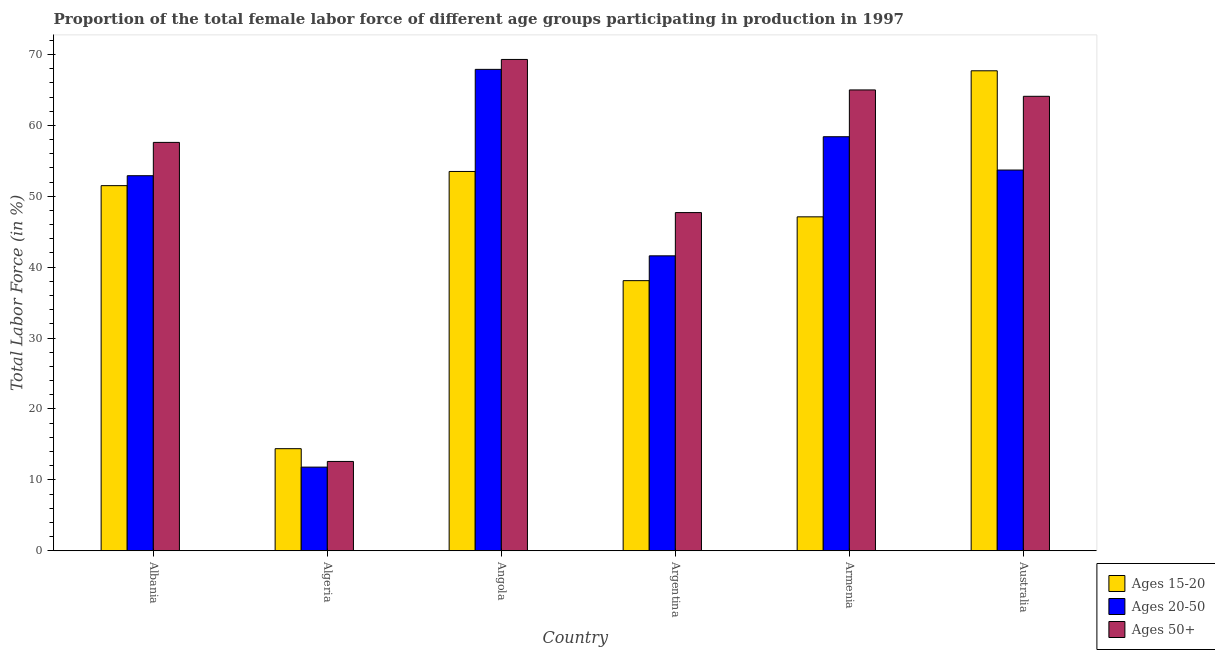How many different coloured bars are there?
Your answer should be compact. 3. Are the number of bars on each tick of the X-axis equal?
Your answer should be compact. Yes. How many bars are there on the 2nd tick from the right?
Your answer should be compact. 3. What is the label of the 3rd group of bars from the left?
Make the answer very short. Angola. In how many cases, is the number of bars for a given country not equal to the number of legend labels?
Give a very brief answer. 0. What is the percentage of female labor force above age 50 in Algeria?
Your response must be concise. 12.6. Across all countries, what is the maximum percentage of female labor force within the age group 15-20?
Provide a short and direct response. 67.7. Across all countries, what is the minimum percentage of female labor force within the age group 15-20?
Your answer should be compact. 14.4. In which country was the percentage of female labor force within the age group 20-50 maximum?
Give a very brief answer. Angola. In which country was the percentage of female labor force within the age group 15-20 minimum?
Ensure brevity in your answer.  Algeria. What is the total percentage of female labor force above age 50 in the graph?
Provide a short and direct response. 316.3. What is the difference between the percentage of female labor force within the age group 20-50 in Albania and that in Angola?
Your response must be concise. -15. What is the difference between the percentage of female labor force within the age group 15-20 in Argentina and the percentage of female labor force above age 50 in Algeria?
Provide a succinct answer. 25.5. What is the average percentage of female labor force within the age group 20-50 per country?
Offer a terse response. 47.72. What is the difference between the percentage of female labor force within the age group 20-50 and percentage of female labor force above age 50 in Armenia?
Your response must be concise. -6.6. What is the ratio of the percentage of female labor force above age 50 in Angola to that in Armenia?
Give a very brief answer. 1.07. What is the difference between the highest and the second highest percentage of female labor force above age 50?
Keep it short and to the point. 4.3. What is the difference between the highest and the lowest percentage of female labor force above age 50?
Offer a terse response. 56.7. Is the sum of the percentage of female labor force above age 50 in Angola and Argentina greater than the maximum percentage of female labor force within the age group 15-20 across all countries?
Provide a short and direct response. Yes. What does the 3rd bar from the left in Algeria represents?
Your answer should be very brief. Ages 50+. What does the 2nd bar from the right in Albania represents?
Ensure brevity in your answer.  Ages 20-50. Is it the case that in every country, the sum of the percentage of female labor force within the age group 15-20 and percentage of female labor force within the age group 20-50 is greater than the percentage of female labor force above age 50?
Your answer should be compact. Yes. Are all the bars in the graph horizontal?
Your answer should be compact. No. How many countries are there in the graph?
Offer a terse response. 6. What is the difference between two consecutive major ticks on the Y-axis?
Offer a terse response. 10. Does the graph contain any zero values?
Offer a very short reply. No. Does the graph contain grids?
Your answer should be compact. No. Where does the legend appear in the graph?
Provide a short and direct response. Bottom right. How many legend labels are there?
Your answer should be very brief. 3. What is the title of the graph?
Make the answer very short. Proportion of the total female labor force of different age groups participating in production in 1997. What is the label or title of the Y-axis?
Give a very brief answer. Total Labor Force (in %). What is the Total Labor Force (in %) of Ages 15-20 in Albania?
Provide a succinct answer. 51.5. What is the Total Labor Force (in %) in Ages 20-50 in Albania?
Your answer should be compact. 52.9. What is the Total Labor Force (in %) of Ages 50+ in Albania?
Your answer should be compact. 57.6. What is the Total Labor Force (in %) in Ages 15-20 in Algeria?
Offer a very short reply. 14.4. What is the Total Labor Force (in %) in Ages 20-50 in Algeria?
Provide a short and direct response. 11.8. What is the Total Labor Force (in %) in Ages 50+ in Algeria?
Offer a terse response. 12.6. What is the Total Labor Force (in %) in Ages 15-20 in Angola?
Offer a very short reply. 53.5. What is the Total Labor Force (in %) in Ages 20-50 in Angola?
Your answer should be very brief. 67.9. What is the Total Labor Force (in %) in Ages 50+ in Angola?
Your response must be concise. 69.3. What is the Total Labor Force (in %) of Ages 15-20 in Argentina?
Offer a terse response. 38.1. What is the Total Labor Force (in %) of Ages 20-50 in Argentina?
Give a very brief answer. 41.6. What is the Total Labor Force (in %) in Ages 50+ in Argentina?
Provide a succinct answer. 47.7. What is the Total Labor Force (in %) in Ages 15-20 in Armenia?
Provide a short and direct response. 47.1. What is the Total Labor Force (in %) in Ages 20-50 in Armenia?
Offer a terse response. 58.4. What is the Total Labor Force (in %) of Ages 15-20 in Australia?
Keep it short and to the point. 67.7. What is the Total Labor Force (in %) in Ages 20-50 in Australia?
Keep it short and to the point. 53.7. What is the Total Labor Force (in %) of Ages 50+ in Australia?
Provide a short and direct response. 64.1. Across all countries, what is the maximum Total Labor Force (in %) of Ages 15-20?
Offer a terse response. 67.7. Across all countries, what is the maximum Total Labor Force (in %) in Ages 20-50?
Your answer should be very brief. 67.9. Across all countries, what is the maximum Total Labor Force (in %) in Ages 50+?
Give a very brief answer. 69.3. Across all countries, what is the minimum Total Labor Force (in %) of Ages 15-20?
Your answer should be compact. 14.4. Across all countries, what is the minimum Total Labor Force (in %) in Ages 20-50?
Your answer should be very brief. 11.8. Across all countries, what is the minimum Total Labor Force (in %) in Ages 50+?
Your response must be concise. 12.6. What is the total Total Labor Force (in %) of Ages 15-20 in the graph?
Keep it short and to the point. 272.3. What is the total Total Labor Force (in %) in Ages 20-50 in the graph?
Offer a terse response. 286.3. What is the total Total Labor Force (in %) in Ages 50+ in the graph?
Offer a terse response. 316.3. What is the difference between the Total Labor Force (in %) of Ages 15-20 in Albania and that in Algeria?
Make the answer very short. 37.1. What is the difference between the Total Labor Force (in %) in Ages 20-50 in Albania and that in Algeria?
Ensure brevity in your answer.  41.1. What is the difference between the Total Labor Force (in %) of Ages 50+ in Albania and that in Algeria?
Provide a short and direct response. 45. What is the difference between the Total Labor Force (in %) of Ages 20-50 in Albania and that in Angola?
Your response must be concise. -15. What is the difference between the Total Labor Force (in %) of Ages 50+ in Albania and that in Argentina?
Ensure brevity in your answer.  9.9. What is the difference between the Total Labor Force (in %) in Ages 15-20 in Albania and that in Armenia?
Your answer should be very brief. 4.4. What is the difference between the Total Labor Force (in %) of Ages 15-20 in Albania and that in Australia?
Your answer should be compact. -16.2. What is the difference between the Total Labor Force (in %) in Ages 15-20 in Algeria and that in Angola?
Your answer should be very brief. -39.1. What is the difference between the Total Labor Force (in %) of Ages 20-50 in Algeria and that in Angola?
Make the answer very short. -56.1. What is the difference between the Total Labor Force (in %) of Ages 50+ in Algeria and that in Angola?
Make the answer very short. -56.7. What is the difference between the Total Labor Force (in %) in Ages 15-20 in Algeria and that in Argentina?
Give a very brief answer. -23.7. What is the difference between the Total Labor Force (in %) in Ages 20-50 in Algeria and that in Argentina?
Your response must be concise. -29.8. What is the difference between the Total Labor Force (in %) of Ages 50+ in Algeria and that in Argentina?
Your answer should be compact. -35.1. What is the difference between the Total Labor Force (in %) of Ages 15-20 in Algeria and that in Armenia?
Provide a succinct answer. -32.7. What is the difference between the Total Labor Force (in %) in Ages 20-50 in Algeria and that in Armenia?
Offer a very short reply. -46.6. What is the difference between the Total Labor Force (in %) in Ages 50+ in Algeria and that in Armenia?
Ensure brevity in your answer.  -52.4. What is the difference between the Total Labor Force (in %) in Ages 15-20 in Algeria and that in Australia?
Give a very brief answer. -53.3. What is the difference between the Total Labor Force (in %) of Ages 20-50 in Algeria and that in Australia?
Your answer should be very brief. -41.9. What is the difference between the Total Labor Force (in %) in Ages 50+ in Algeria and that in Australia?
Ensure brevity in your answer.  -51.5. What is the difference between the Total Labor Force (in %) in Ages 20-50 in Angola and that in Argentina?
Keep it short and to the point. 26.3. What is the difference between the Total Labor Force (in %) of Ages 50+ in Angola and that in Argentina?
Offer a terse response. 21.6. What is the difference between the Total Labor Force (in %) of Ages 15-20 in Angola and that in Australia?
Your response must be concise. -14.2. What is the difference between the Total Labor Force (in %) in Ages 20-50 in Angola and that in Australia?
Your answer should be very brief. 14.2. What is the difference between the Total Labor Force (in %) of Ages 50+ in Angola and that in Australia?
Provide a succinct answer. 5.2. What is the difference between the Total Labor Force (in %) in Ages 15-20 in Argentina and that in Armenia?
Provide a short and direct response. -9. What is the difference between the Total Labor Force (in %) in Ages 20-50 in Argentina and that in Armenia?
Make the answer very short. -16.8. What is the difference between the Total Labor Force (in %) in Ages 50+ in Argentina and that in Armenia?
Ensure brevity in your answer.  -17.3. What is the difference between the Total Labor Force (in %) in Ages 15-20 in Argentina and that in Australia?
Your answer should be very brief. -29.6. What is the difference between the Total Labor Force (in %) in Ages 20-50 in Argentina and that in Australia?
Offer a very short reply. -12.1. What is the difference between the Total Labor Force (in %) of Ages 50+ in Argentina and that in Australia?
Your answer should be compact. -16.4. What is the difference between the Total Labor Force (in %) of Ages 15-20 in Armenia and that in Australia?
Your answer should be compact. -20.6. What is the difference between the Total Labor Force (in %) of Ages 20-50 in Armenia and that in Australia?
Your answer should be compact. 4.7. What is the difference between the Total Labor Force (in %) in Ages 15-20 in Albania and the Total Labor Force (in %) in Ages 20-50 in Algeria?
Give a very brief answer. 39.7. What is the difference between the Total Labor Force (in %) of Ages 15-20 in Albania and the Total Labor Force (in %) of Ages 50+ in Algeria?
Make the answer very short. 38.9. What is the difference between the Total Labor Force (in %) in Ages 20-50 in Albania and the Total Labor Force (in %) in Ages 50+ in Algeria?
Give a very brief answer. 40.3. What is the difference between the Total Labor Force (in %) of Ages 15-20 in Albania and the Total Labor Force (in %) of Ages 20-50 in Angola?
Your answer should be compact. -16.4. What is the difference between the Total Labor Force (in %) in Ages 15-20 in Albania and the Total Labor Force (in %) in Ages 50+ in Angola?
Offer a very short reply. -17.8. What is the difference between the Total Labor Force (in %) in Ages 20-50 in Albania and the Total Labor Force (in %) in Ages 50+ in Angola?
Ensure brevity in your answer.  -16.4. What is the difference between the Total Labor Force (in %) in Ages 15-20 in Albania and the Total Labor Force (in %) in Ages 20-50 in Argentina?
Offer a very short reply. 9.9. What is the difference between the Total Labor Force (in %) in Ages 15-20 in Albania and the Total Labor Force (in %) in Ages 50+ in Argentina?
Offer a very short reply. 3.8. What is the difference between the Total Labor Force (in %) in Ages 20-50 in Albania and the Total Labor Force (in %) in Ages 50+ in Argentina?
Offer a terse response. 5.2. What is the difference between the Total Labor Force (in %) in Ages 15-20 in Albania and the Total Labor Force (in %) in Ages 20-50 in Armenia?
Offer a terse response. -6.9. What is the difference between the Total Labor Force (in %) of Ages 15-20 in Albania and the Total Labor Force (in %) of Ages 50+ in Armenia?
Provide a short and direct response. -13.5. What is the difference between the Total Labor Force (in %) in Ages 20-50 in Albania and the Total Labor Force (in %) in Ages 50+ in Armenia?
Provide a short and direct response. -12.1. What is the difference between the Total Labor Force (in %) in Ages 15-20 in Albania and the Total Labor Force (in %) in Ages 50+ in Australia?
Offer a terse response. -12.6. What is the difference between the Total Labor Force (in %) of Ages 15-20 in Algeria and the Total Labor Force (in %) of Ages 20-50 in Angola?
Your answer should be compact. -53.5. What is the difference between the Total Labor Force (in %) in Ages 15-20 in Algeria and the Total Labor Force (in %) in Ages 50+ in Angola?
Your response must be concise. -54.9. What is the difference between the Total Labor Force (in %) in Ages 20-50 in Algeria and the Total Labor Force (in %) in Ages 50+ in Angola?
Keep it short and to the point. -57.5. What is the difference between the Total Labor Force (in %) of Ages 15-20 in Algeria and the Total Labor Force (in %) of Ages 20-50 in Argentina?
Your answer should be compact. -27.2. What is the difference between the Total Labor Force (in %) in Ages 15-20 in Algeria and the Total Labor Force (in %) in Ages 50+ in Argentina?
Make the answer very short. -33.3. What is the difference between the Total Labor Force (in %) in Ages 20-50 in Algeria and the Total Labor Force (in %) in Ages 50+ in Argentina?
Provide a succinct answer. -35.9. What is the difference between the Total Labor Force (in %) of Ages 15-20 in Algeria and the Total Labor Force (in %) of Ages 20-50 in Armenia?
Provide a succinct answer. -44. What is the difference between the Total Labor Force (in %) in Ages 15-20 in Algeria and the Total Labor Force (in %) in Ages 50+ in Armenia?
Your response must be concise. -50.6. What is the difference between the Total Labor Force (in %) of Ages 20-50 in Algeria and the Total Labor Force (in %) of Ages 50+ in Armenia?
Make the answer very short. -53.2. What is the difference between the Total Labor Force (in %) of Ages 15-20 in Algeria and the Total Labor Force (in %) of Ages 20-50 in Australia?
Your response must be concise. -39.3. What is the difference between the Total Labor Force (in %) in Ages 15-20 in Algeria and the Total Labor Force (in %) in Ages 50+ in Australia?
Your response must be concise. -49.7. What is the difference between the Total Labor Force (in %) in Ages 20-50 in Algeria and the Total Labor Force (in %) in Ages 50+ in Australia?
Your answer should be compact. -52.3. What is the difference between the Total Labor Force (in %) of Ages 15-20 in Angola and the Total Labor Force (in %) of Ages 50+ in Argentina?
Make the answer very short. 5.8. What is the difference between the Total Labor Force (in %) in Ages 20-50 in Angola and the Total Labor Force (in %) in Ages 50+ in Argentina?
Your response must be concise. 20.2. What is the difference between the Total Labor Force (in %) of Ages 15-20 in Angola and the Total Labor Force (in %) of Ages 20-50 in Armenia?
Provide a short and direct response. -4.9. What is the difference between the Total Labor Force (in %) in Ages 15-20 in Angola and the Total Labor Force (in %) in Ages 50+ in Armenia?
Keep it short and to the point. -11.5. What is the difference between the Total Labor Force (in %) of Ages 20-50 in Angola and the Total Labor Force (in %) of Ages 50+ in Armenia?
Offer a terse response. 2.9. What is the difference between the Total Labor Force (in %) of Ages 15-20 in Angola and the Total Labor Force (in %) of Ages 20-50 in Australia?
Your answer should be very brief. -0.2. What is the difference between the Total Labor Force (in %) of Ages 15-20 in Angola and the Total Labor Force (in %) of Ages 50+ in Australia?
Your answer should be compact. -10.6. What is the difference between the Total Labor Force (in %) of Ages 15-20 in Argentina and the Total Labor Force (in %) of Ages 20-50 in Armenia?
Provide a succinct answer. -20.3. What is the difference between the Total Labor Force (in %) of Ages 15-20 in Argentina and the Total Labor Force (in %) of Ages 50+ in Armenia?
Your answer should be compact. -26.9. What is the difference between the Total Labor Force (in %) in Ages 20-50 in Argentina and the Total Labor Force (in %) in Ages 50+ in Armenia?
Keep it short and to the point. -23.4. What is the difference between the Total Labor Force (in %) of Ages 15-20 in Argentina and the Total Labor Force (in %) of Ages 20-50 in Australia?
Provide a succinct answer. -15.6. What is the difference between the Total Labor Force (in %) in Ages 15-20 in Argentina and the Total Labor Force (in %) in Ages 50+ in Australia?
Your answer should be very brief. -26. What is the difference between the Total Labor Force (in %) of Ages 20-50 in Argentina and the Total Labor Force (in %) of Ages 50+ in Australia?
Offer a terse response. -22.5. What is the difference between the Total Labor Force (in %) in Ages 15-20 in Armenia and the Total Labor Force (in %) in Ages 20-50 in Australia?
Provide a succinct answer. -6.6. What is the difference between the Total Labor Force (in %) of Ages 15-20 in Armenia and the Total Labor Force (in %) of Ages 50+ in Australia?
Offer a very short reply. -17. What is the average Total Labor Force (in %) of Ages 15-20 per country?
Your response must be concise. 45.38. What is the average Total Labor Force (in %) in Ages 20-50 per country?
Offer a terse response. 47.72. What is the average Total Labor Force (in %) of Ages 50+ per country?
Your answer should be compact. 52.72. What is the difference between the Total Labor Force (in %) of Ages 15-20 and Total Labor Force (in %) of Ages 20-50 in Albania?
Make the answer very short. -1.4. What is the difference between the Total Labor Force (in %) of Ages 15-20 and Total Labor Force (in %) of Ages 50+ in Albania?
Ensure brevity in your answer.  -6.1. What is the difference between the Total Labor Force (in %) in Ages 15-20 and Total Labor Force (in %) in Ages 20-50 in Algeria?
Give a very brief answer. 2.6. What is the difference between the Total Labor Force (in %) of Ages 15-20 and Total Labor Force (in %) of Ages 20-50 in Angola?
Your response must be concise. -14.4. What is the difference between the Total Labor Force (in %) in Ages 15-20 and Total Labor Force (in %) in Ages 50+ in Angola?
Give a very brief answer. -15.8. What is the difference between the Total Labor Force (in %) of Ages 20-50 and Total Labor Force (in %) of Ages 50+ in Angola?
Keep it short and to the point. -1.4. What is the difference between the Total Labor Force (in %) in Ages 15-20 and Total Labor Force (in %) in Ages 20-50 in Argentina?
Give a very brief answer. -3.5. What is the difference between the Total Labor Force (in %) of Ages 15-20 and Total Labor Force (in %) of Ages 50+ in Armenia?
Provide a short and direct response. -17.9. What is the difference between the Total Labor Force (in %) of Ages 20-50 and Total Labor Force (in %) of Ages 50+ in Armenia?
Make the answer very short. -6.6. What is the difference between the Total Labor Force (in %) of Ages 15-20 and Total Labor Force (in %) of Ages 50+ in Australia?
Offer a very short reply. 3.6. What is the ratio of the Total Labor Force (in %) in Ages 15-20 in Albania to that in Algeria?
Offer a terse response. 3.58. What is the ratio of the Total Labor Force (in %) in Ages 20-50 in Albania to that in Algeria?
Keep it short and to the point. 4.48. What is the ratio of the Total Labor Force (in %) of Ages 50+ in Albania to that in Algeria?
Keep it short and to the point. 4.57. What is the ratio of the Total Labor Force (in %) of Ages 15-20 in Albania to that in Angola?
Make the answer very short. 0.96. What is the ratio of the Total Labor Force (in %) in Ages 20-50 in Albania to that in Angola?
Make the answer very short. 0.78. What is the ratio of the Total Labor Force (in %) in Ages 50+ in Albania to that in Angola?
Keep it short and to the point. 0.83. What is the ratio of the Total Labor Force (in %) of Ages 15-20 in Albania to that in Argentina?
Ensure brevity in your answer.  1.35. What is the ratio of the Total Labor Force (in %) in Ages 20-50 in Albania to that in Argentina?
Your response must be concise. 1.27. What is the ratio of the Total Labor Force (in %) of Ages 50+ in Albania to that in Argentina?
Offer a very short reply. 1.21. What is the ratio of the Total Labor Force (in %) in Ages 15-20 in Albania to that in Armenia?
Your response must be concise. 1.09. What is the ratio of the Total Labor Force (in %) in Ages 20-50 in Albania to that in Armenia?
Keep it short and to the point. 0.91. What is the ratio of the Total Labor Force (in %) in Ages 50+ in Albania to that in Armenia?
Give a very brief answer. 0.89. What is the ratio of the Total Labor Force (in %) in Ages 15-20 in Albania to that in Australia?
Offer a very short reply. 0.76. What is the ratio of the Total Labor Force (in %) of Ages 20-50 in Albania to that in Australia?
Offer a very short reply. 0.99. What is the ratio of the Total Labor Force (in %) of Ages 50+ in Albania to that in Australia?
Ensure brevity in your answer.  0.9. What is the ratio of the Total Labor Force (in %) of Ages 15-20 in Algeria to that in Angola?
Provide a short and direct response. 0.27. What is the ratio of the Total Labor Force (in %) in Ages 20-50 in Algeria to that in Angola?
Offer a very short reply. 0.17. What is the ratio of the Total Labor Force (in %) in Ages 50+ in Algeria to that in Angola?
Make the answer very short. 0.18. What is the ratio of the Total Labor Force (in %) in Ages 15-20 in Algeria to that in Argentina?
Your answer should be compact. 0.38. What is the ratio of the Total Labor Force (in %) of Ages 20-50 in Algeria to that in Argentina?
Make the answer very short. 0.28. What is the ratio of the Total Labor Force (in %) of Ages 50+ in Algeria to that in Argentina?
Give a very brief answer. 0.26. What is the ratio of the Total Labor Force (in %) in Ages 15-20 in Algeria to that in Armenia?
Your answer should be compact. 0.31. What is the ratio of the Total Labor Force (in %) in Ages 20-50 in Algeria to that in Armenia?
Your answer should be compact. 0.2. What is the ratio of the Total Labor Force (in %) in Ages 50+ in Algeria to that in Armenia?
Ensure brevity in your answer.  0.19. What is the ratio of the Total Labor Force (in %) in Ages 15-20 in Algeria to that in Australia?
Your response must be concise. 0.21. What is the ratio of the Total Labor Force (in %) in Ages 20-50 in Algeria to that in Australia?
Keep it short and to the point. 0.22. What is the ratio of the Total Labor Force (in %) in Ages 50+ in Algeria to that in Australia?
Ensure brevity in your answer.  0.2. What is the ratio of the Total Labor Force (in %) in Ages 15-20 in Angola to that in Argentina?
Offer a very short reply. 1.4. What is the ratio of the Total Labor Force (in %) in Ages 20-50 in Angola to that in Argentina?
Your answer should be compact. 1.63. What is the ratio of the Total Labor Force (in %) in Ages 50+ in Angola to that in Argentina?
Ensure brevity in your answer.  1.45. What is the ratio of the Total Labor Force (in %) in Ages 15-20 in Angola to that in Armenia?
Offer a terse response. 1.14. What is the ratio of the Total Labor Force (in %) of Ages 20-50 in Angola to that in Armenia?
Give a very brief answer. 1.16. What is the ratio of the Total Labor Force (in %) in Ages 50+ in Angola to that in Armenia?
Ensure brevity in your answer.  1.07. What is the ratio of the Total Labor Force (in %) of Ages 15-20 in Angola to that in Australia?
Your answer should be compact. 0.79. What is the ratio of the Total Labor Force (in %) of Ages 20-50 in Angola to that in Australia?
Provide a short and direct response. 1.26. What is the ratio of the Total Labor Force (in %) in Ages 50+ in Angola to that in Australia?
Your answer should be very brief. 1.08. What is the ratio of the Total Labor Force (in %) of Ages 15-20 in Argentina to that in Armenia?
Make the answer very short. 0.81. What is the ratio of the Total Labor Force (in %) of Ages 20-50 in Argentina to that in Armenia?
Your answer should be very brief. 0.71. What is the ratio of the Total Labor Force (in %) in Ages 50+ in Argentina to that in Armenia?
Provide a succinct answer. 0.73. What is the ratio of the Total Labor Force (in %) in Ages 15-20 in Argentina to that in Australia?
Give a very brief answer. 0.56. What is the ratio of the Total Labor Force (in %) in Ages 20-50 in Argentina to that in Australia?
Your answer should be very brief. 0.77. What is the ratio of the Total Labor Force (in %) in Ages 50+ in Argentina to that in Australia?
Give a very brief answer. 0.74. What is the ratio of the Total Labor Force (in %) of Ages 15-20 in Armenia to that in Australia?
Provide a short and direct response. 0.7. What is the ratio of the Total Labor Force (in %) of Ages 20-50 in Armenia to that in Australia?
Offer a terse response. 1.09. What is the ratio of the Total Labor Force (in %) in Ages 50+ in Armenia to that in Australia?
Ensure brevity in your answer.  1.01. What is the difference between the highest and the second highest Total Labor Force (in %) in Ages 15-20?
Your response must be concise. 14.2. What is the difference between the highest and the second highest Total Labor Force (in %) in Ages 20-50?
Ensure brevity in your answer.  9.5. What is the difference between the highest and the second highest Total Labor Force (in %) of Ages 50+?
Your answer should be compact. 4.3. What is the difference between the highest and the lowest Total Labor Force (in %) in Ages 15-20?
Ensure brevity in your answer.  53.3. What is the difference between the highest and the lowest Total Labor Force (in %) of Ages 20-50?
Offer a very short reply. 56.1. What is the difference between the highest and the lowest Total Labor Force (in %) in Ages 50+?
Your answer should be very brief. 56.7. 